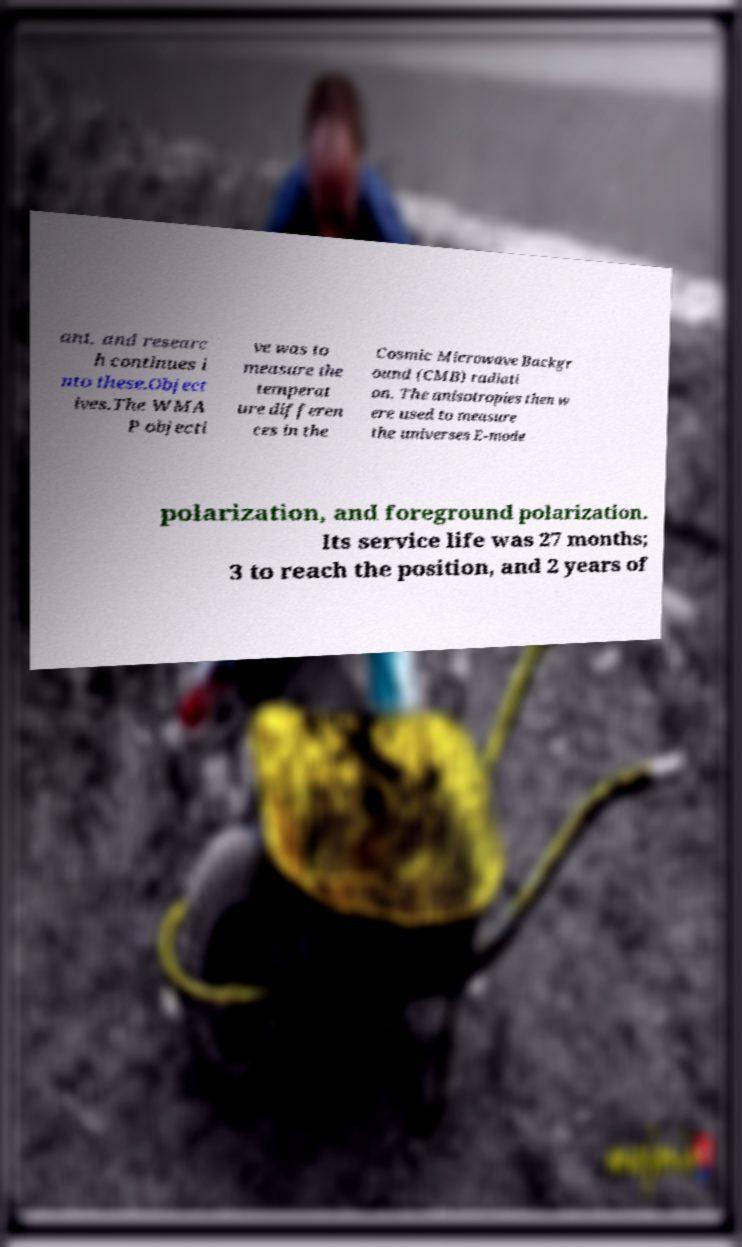Can you read and provide the text displayed in the image?This photo seems to have some interesting text. Can you extract and type it out for me? ant, and researc h continues i nto these.Object ives.The WMA P objecti ve was to measure the temperat ure differen ces in the Cosmic Microwave Backgr ound (CMB) radiati on. The anisotropies then w ere used to measure the universes E-mode polarization, and foreground polarization. Its service life was 27 months; 3 to reach the position, and 2 years of 